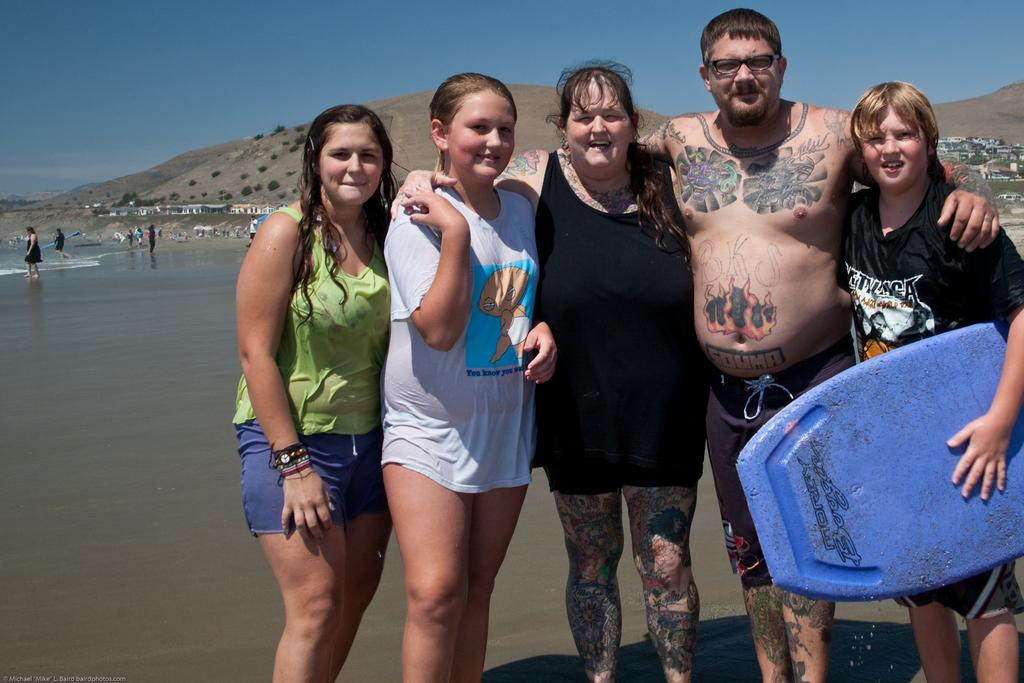Who or what can be seen in the image? There are people in the image. What is the primary natural element visible in the image? There is water visible in the image. What type of structures are present in the image? There are houses in the image. What type of vegetation is present in the image? Trees are present in the image. What type of geographical feature is present in the image? There are hills in the image. What is visible in the sky in the image? The sky is visible in the image. How many dinosaurs can be seen in the image? There are no dinosaurs present in the image. What type of frogs can be seen in the image? There are no frogs present in the image. 